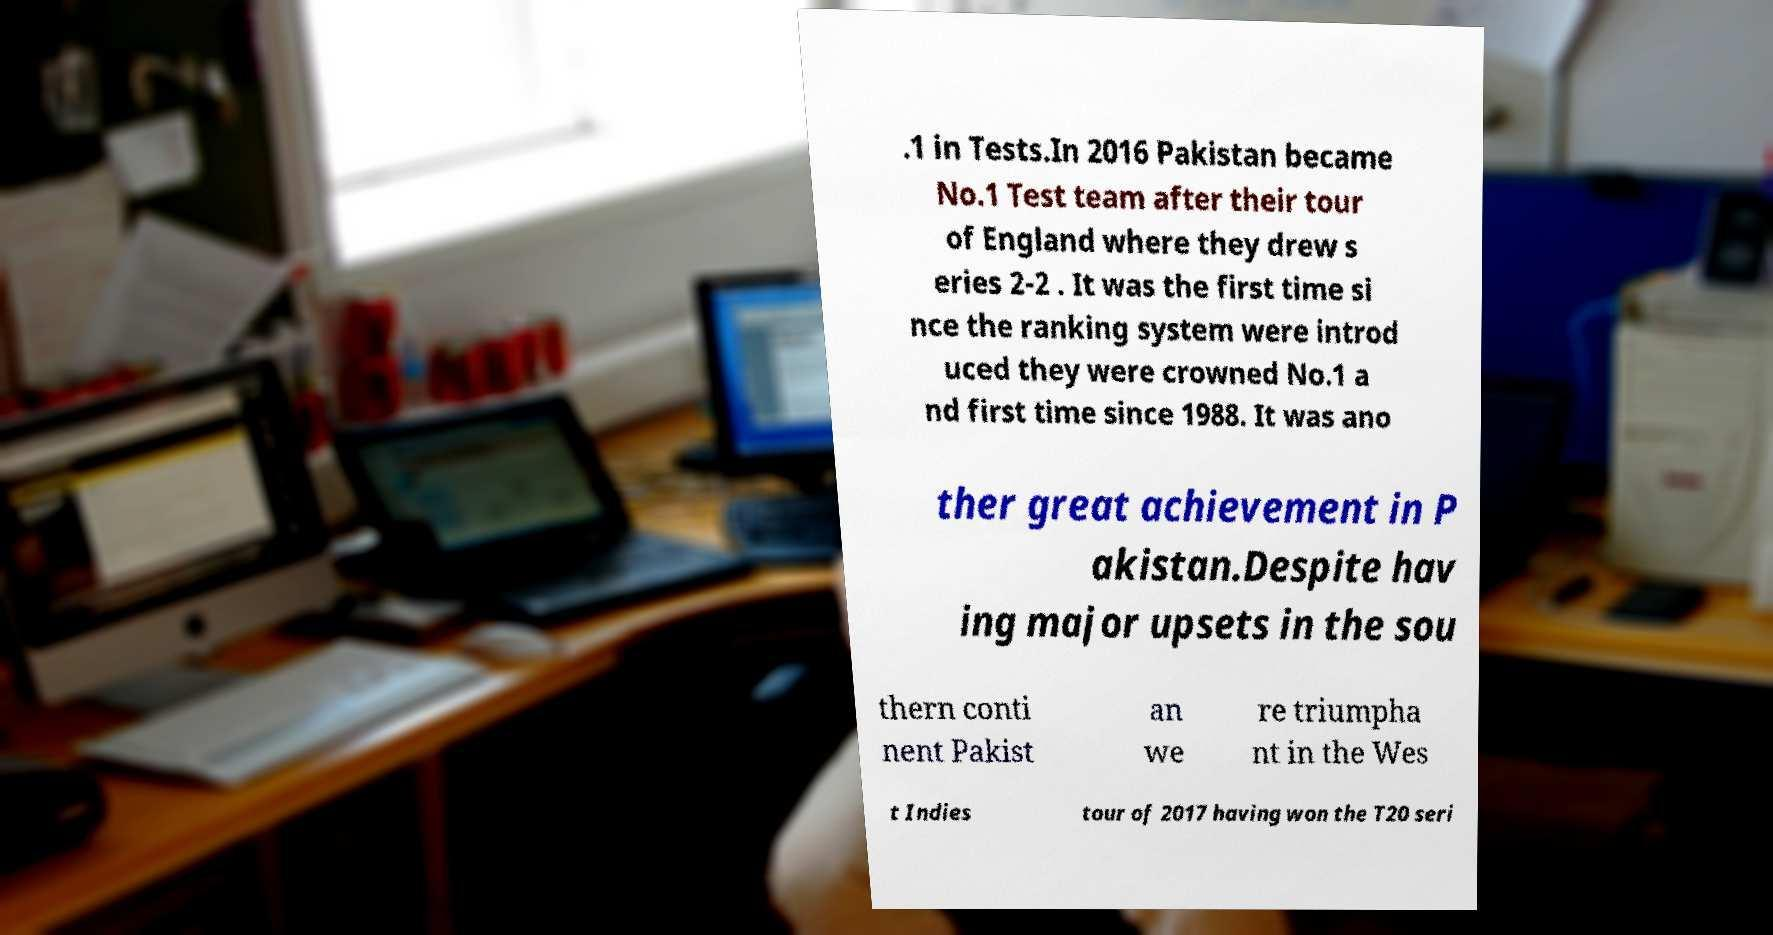I need the written content from this picture converted into text. Can you do that? .1 in Tests.In 2016 Pakistan became No.1 Test team after their tour of England where they drew s eries 2-2 . It was the first time si nce the ranking system were introd uced they were crowned No.1 a nd first time since 1988. It was ano ther great achievement in P akistan.Despite hav ing major upsets in the sou thern conti nent Pakist an we re triumpha nt in the Wes t Indies tour of 2017 having won the T20 seri 